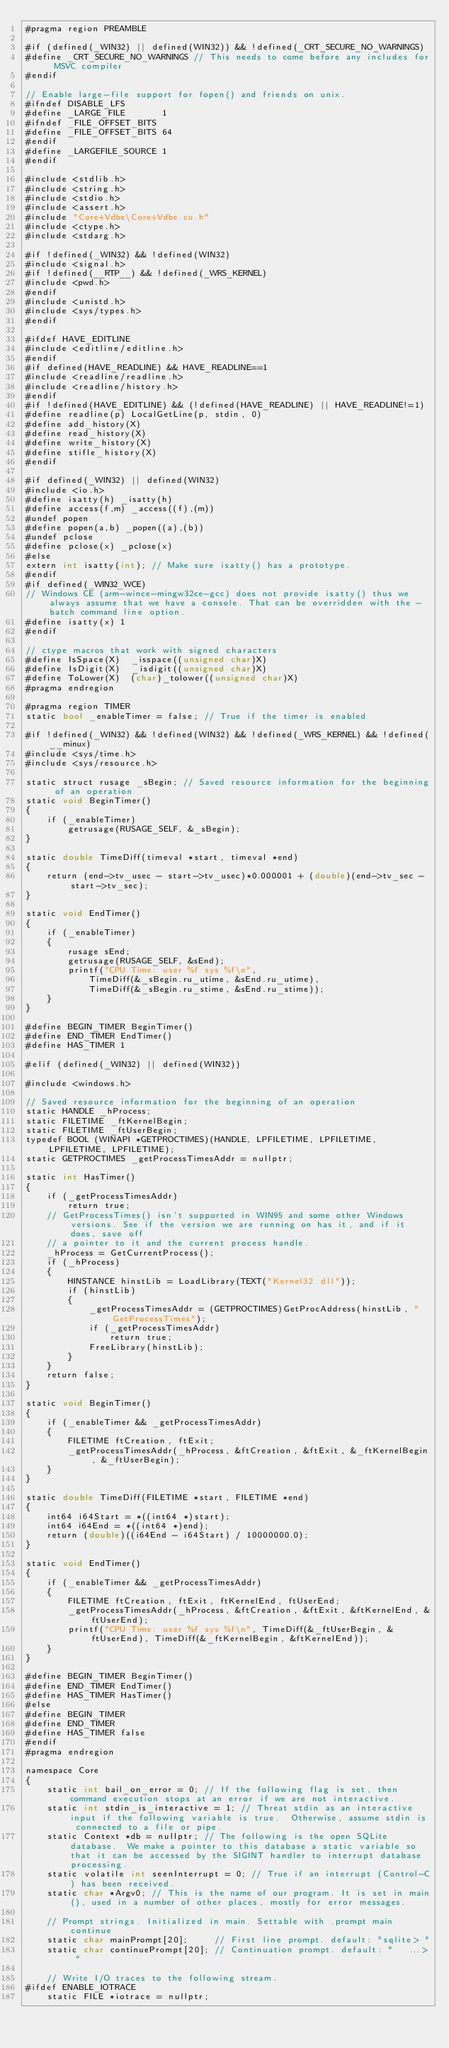Convert code to text. <code><loc_0><loc_0><loc_500><loc_500><_Cuda_>#pragma region PREAMBLE

#if (defined(_WIN32) || defined(WIN32)) && !defined(_CRT_SECURE_NO_WARNINGS)
#define _CRT_SECURE_NO_WARNINGS // This needs to come before any includes for MSVC compiler
#endif

// Enable large-file support for fopen() and friends on unix.
#ifndef DISABLE_LFS
#define _LARGE_FILE       1
#ifndef _FILE_OFFSET_BITS
#define _FILE_OFFSET_BITS 64
#endif
#define _LARGEFILE_SOURCE 1
#endif

#include <stdlib.h>
#include <string.h>
#include <stdio.h>
#include <assert.h>
#include "Core+Vdbe\Core+Vdbe.cu.h"
#include <ctype.h>
#include <stdarg.h>

#if !defined(_WIN32) && !defined(WIN32)
#include <signal.h>
#if !defined(__RTP__) && !defined(_WRS_KERNEL)
#include <pwd.h>
#endif
#include <unistd.h>
#include <sys/types.h>
#endif

#ifdef HAVE_EDITLINE
#include <editline/editline.h>
#endif
#if defined(HAVE_READLINE) && HAVE_READLINE==1
#include <readline/readline.h>
#include <readline/history.h>
#endif
#if !defined(HAVE_EDITLINE) && (!defined(HAVE_READLINE) || HAVE_READLINE!=1)
#define readline(p) LocalGetLine(p, stdin, 0)
#define add_history(X)
#define read_history(X)
#define write_history(X)
#define stifle_history(X)
#endif

#if defined(_WIN32) || defined(WIN32)
#include <io.h>
#define isatty(h) _isatty(h)
#define access(f,m) _access((f),(m))
#undef popen
#define popen(a,b) _popen((a),(b))
#undef pclose
#define pclose(x) _pclose(x)
#else
extern int isatty(int); // Make sure isatty() has a prototype.
#endif
#if defined(_WIN32_WCE)
// Windows CE (arm-wince-mingw32ce-gcc) does not provide isatty() thus we always assume that we have a console. That can be overridden with the -batch command line option.
#define isatty(x) 1
#endif

// ctype macros that work with signed characters
#define IsSpace(X)  _isspace((unsigned char)X)
#define IsDigit(X)  _isdigit((unsigned char)X)
#define ToLower(X)  (char)_tolower((unsigned char)X)
#pragma endregion

#pragma region TIMER
static bool _enableTimer = false; // True if the timer is enabled

#if !defined(_WIN32) && !defined(WIN32) && !defined(_WRS_KERNEL) && !defined(__minux)
#include <sys/time.h>
#include <sys/resource.h>

static struct rusage _sBegin; // Saved resource information for the beginning of an operation
static void BeginTimer()
{
	if (_enableTimer)
		getrusage(RUSAGE_SELF, &_sBegin);
}

static double TimeDiff(timeval *start, timeval *end)
{
	return (end->tv_usec - start->tv_usec)*0.000001 + (double)(end->tv_sec - start->tv_sec);
}

static void EndTimer()
{
	if (_enableTimer)
	{
		rusage sEnd;
		getrusage(RUSAGE_SELF, &sEnd);
		printf("CPU Time: user %f sys %f\n",
			TimeDiff(&_sBegin.ru_utime, &sEnd.ru_utime),
			TimeDiff(&_sBegin.ru_stime, &sEnd.ru_stime));
	}
}

#define BEGIN_TIMER BeginTimer()
#define END_TIMER EndTimer()
#define HAS_TIMER 1

#elif (defined(_WIN32) || defined(WIN32))

#include <windows.h>

// Saved resource information for the beginning of an operation
static HANDLE _hProcess;
static FILETIME _ftKernelBegin;
static FILETIME _ftUserBegin;
typedef BOOL (WINAPI *GETPROCTIMES)(HANDLE, LPFILETIME, LPFILETIME, LPFILETIME, LPFILETIME);
static GETPROCTIMES _getProcessTimesAddr = nullptr;

static int HasTimer()
{
	if (_getProcessTimesAddr)
		return true;
	// GetProcessTimes() isn't supported in WIN95 and some other Windows versions. See if the version we are running on has it, and if it does, save off
	// a pointer to it and the current process handle.
	_hProcess = GetCurrentProcess();
	if (_hProcess)
	{
		HINSTANCE hinstLib = LoadLibrary(TEXT("Kernel32.dll"));
		if (hinstLib)
		{
			_getProcessTimesAddr = (GETPROCTIMES)GetProcAddress(hinstLib, "GetProcessTimes");
			if (_getProcessTimesAddr)
				return true;
			FreeLibrary(hinstLib); 
		}
	}
	return false;
}

static void BeginTimer()
{
	if (_enableTimer && _getProcessTimesAddr)
	{
		FILETIME ftCreation, ftExit;
		_getProcessTimesAddr(_hProcess, &ftCreation, &ftExit, &_ftKernelBegin, &_ftUserBegin);
	}
}

static double TimeDiff(FILETIME *start, FILETIME *end)
{
	int64 i64Start = *((int64 *)start);
	int64 i64End = *((int64 *)end);
	return (double)((i64End - i64Start) / 10000000.0);
}

static void EndTimer()
{
	if (_enableTimer && _getProcessTimesAddr)
	{
		FILETIME ftCreation, ftExit, ftKernelEnd, ftUserEnd;
		_getProcessTimesAddr(_hProcess, &ftCreation, &ftExit, &ftKernelEnd, &ftUserEnd);
		printf("CPU Time: user %f sys %f\n", TimeDiff(&_ftUserBegin, &ftUserEnd), TimeDiff(&_ftKernelBegin, &ftKernelEnd));
	}
}

#define BEGIN_TIMER BeginTimer()
#define END_TIMER EndTimer()
#define HAS_TIMER HasTimer()
#else
#define BEGIN_TIMER 
#define END_TIMER
#define HAS_TIMER false
#endif
#pragma endregion

namespace Core
{
	static int bail_on_error = 0; // If the following flag is set, then command execution stops at an error if we are not interactive.
	static int stdin_is_interactive = 1; // Threat stdin as an interactive input if the following variable is true.  Otherwise, assume stdin is connected to a file or pipe.
	static Context *db = nullptr; // The following is the open SQLite database.  We make a pointer to this database a static variable so that it can be accessed by the SIGINT handler to interrupt database processing.
	static volatile int seenInterrupt = 0; // True if an interrupt (Control-C) has been received.
	static char *Argv0; // This is the name of our program. It is set in main(), used in a number of other places, mostly for error messages.

	// Prompt strings. Initialized in main. Settable with .prompt main continue
	static char mainPrompt[20];     // First line prompt. default: "sqlite> "
	static char continuePrompt[20]; // Continuation prompt. default: "   ...> "

	// Write I/O traces to the following stream.
#ifdef ENABLE_IOTRACE
	static FILE *iotrace = nullptr;
</code> 